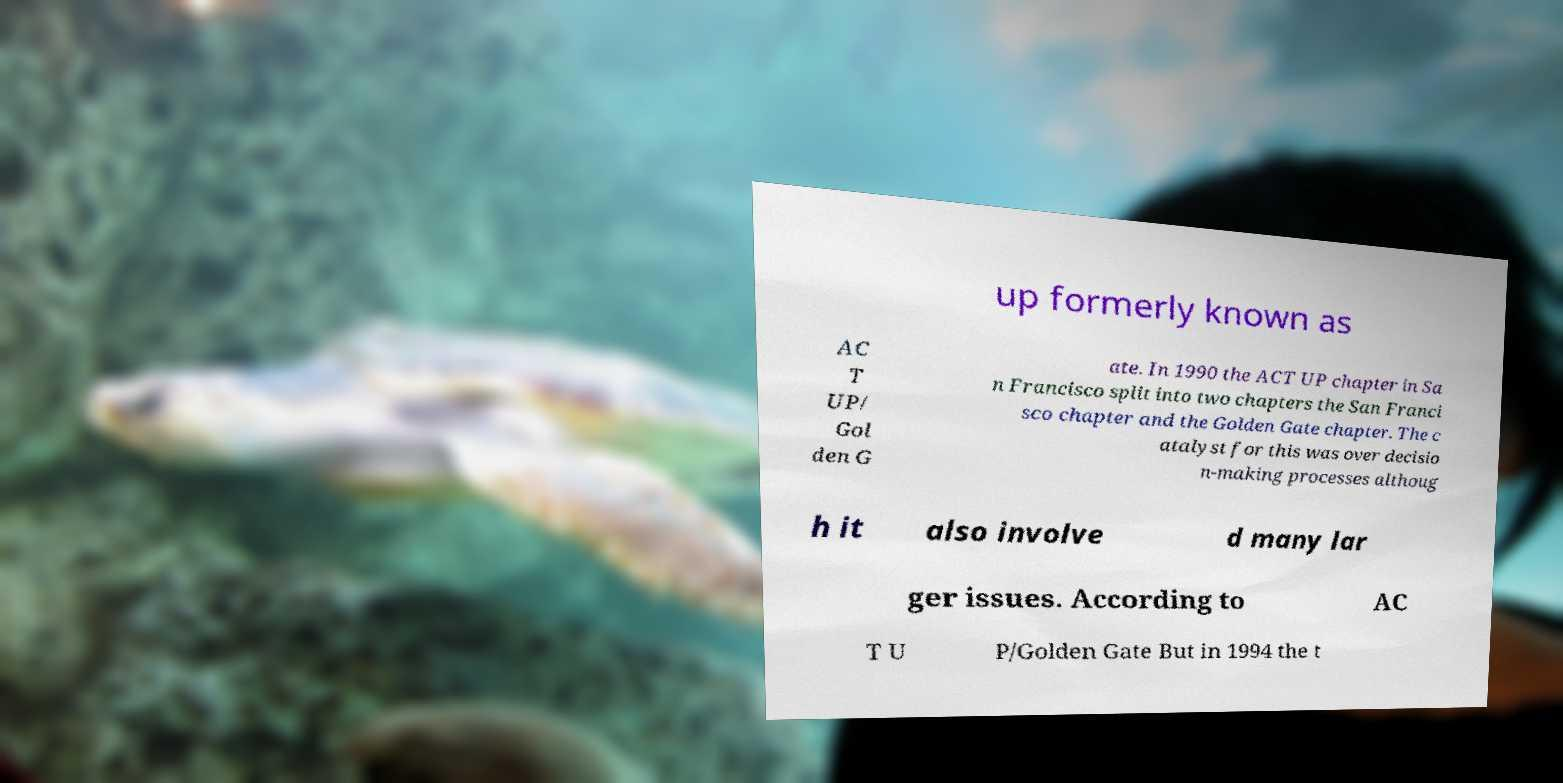Can you read and provide the text displayed in the image?This photo seems to have some interesting text. Can you extract and type it out for me? up formerly known as AC T UP/ Gol den G ate. In 1990 the ACT UP chapter in Sa n Francisco split into two chapters the San Franci sco chapter and the Golden Gate chapter. The c atalyst for this was over decisio n-making processes althoug h it also involve d many lar ger issues. According to AC T U P/Golden Gate But in 1994 the t 